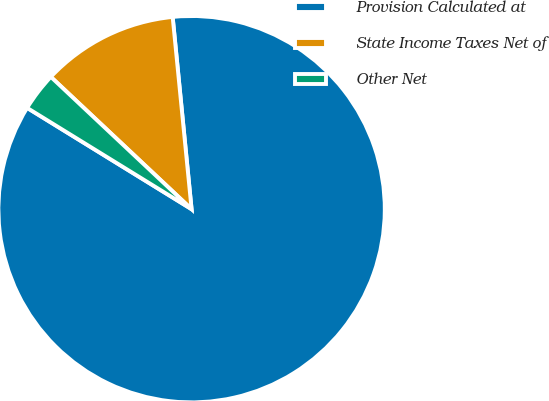Convert chart to OTSL. <chart><loc_0><loc_0><loc_500><loc_500><pie_chart><fcel>Provision Calculated at<fcel>State Income Taxes Net of<fcel>Other Net<nl><fcel>85.35%<fcel>11.43%<fcel>3.22%<nl></chart> 